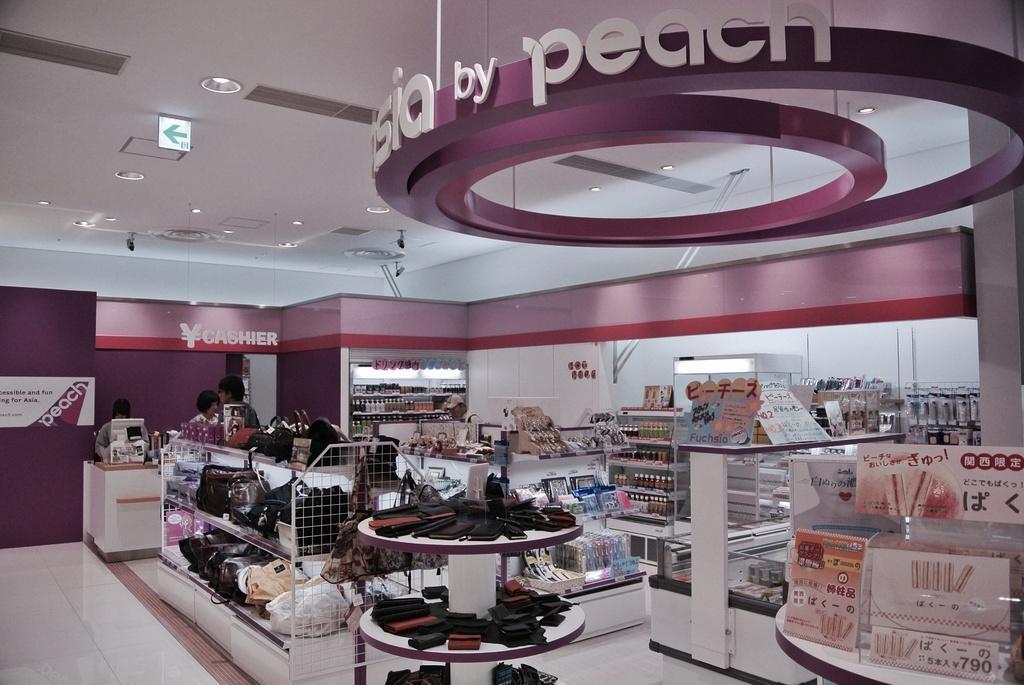Can you describe this image briefly? This image is clicked in a shop. In the front, we can see the wallets kept in the rack. Beside that, there are handbags. At the bottom, there is a floor. In the background, there are many things. On the left, we can see a bill counter near which there are three persons standing. At the top, there is a roof. 